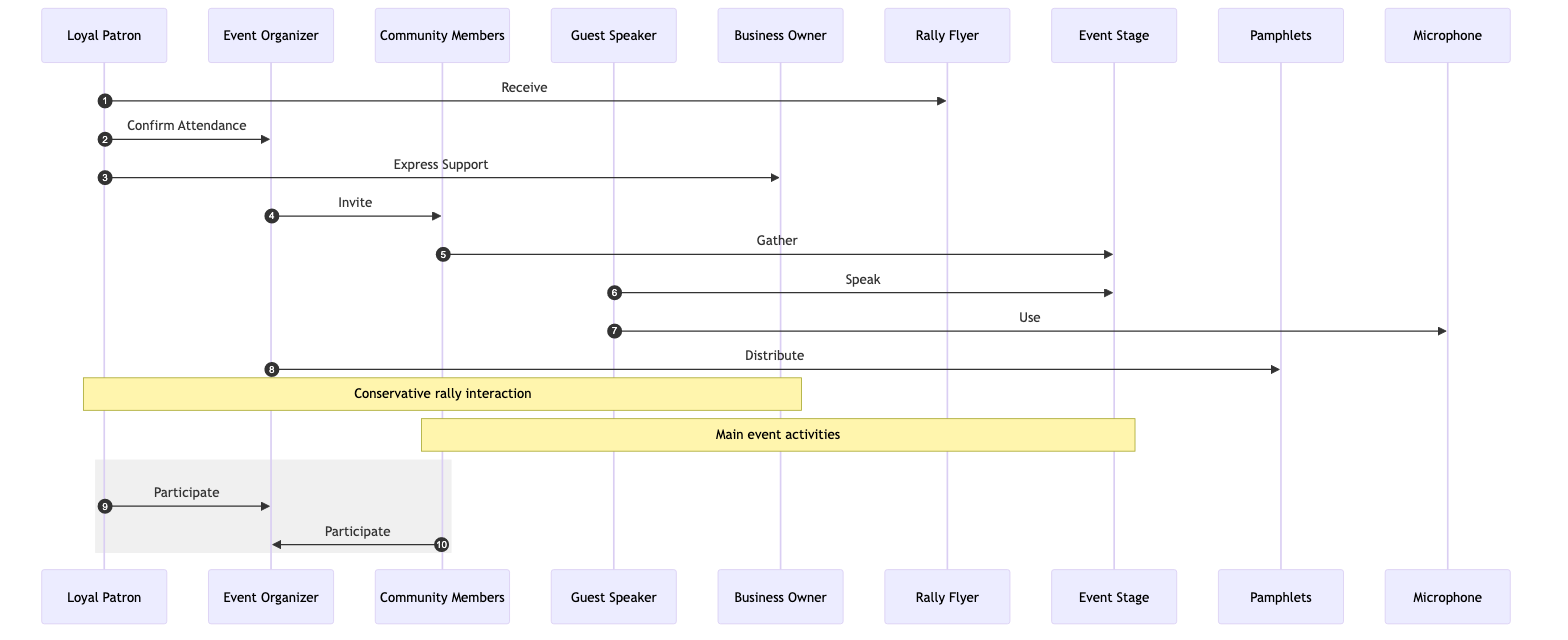What is the first action taken by the Loyal Patron? The first action listed in the interaction sequence is the Loyal Patron receiving the Rally Flyer. This is shown as the first arrow pointing from the Loyal Patron to the Rally Flyer in the diagram.
Answer: Receive Who does the Event Organizer invite? According to the interactions, the Event Organizer invites Community Members. This is explicitly stated in the action connecting the Event Organizer to the Community Members.
Answer: Community Members How many documents are involved in the interactions? The diagram shows two documents: the Rally Flyer and Pamphlets. Counting these gives a total of two documents mentioned in the interactions.
Answer: 2 What equipment does the Guest Speaker use during the rally? The diagram indicates that the Guest Speaker uses a Microphone during their interaction at the Event Stage, as shown in the separate action connecting the Guest Speaker to the Microphone.
Answer: Microphone What is the final action taken by the Event Organizer? The final action taken by the Event Organizer in the sequence is to distribute Pamphlets to the participants, as illustrated by the last interaction connecting the Event Organizer to the Pamphlets.
Answer: Distribute How is the Loyal Patron's relationship with the Business Owner characterized in the diagram? The Loyal Patron expresses support to the Business Owner, indicating a positive relationship and engagement. This is represented by the interaction between these two actors in the diagram.
Answer: Express Support What do the Community Members do after being invited? After being invited by the Event Organizer, the Community Members gather at the Event Stage, as indicated by the subsequent interaction in the flow of the diagram.
Answer: Gather What occurs between the Loyal Patron and the Event Organizer? The Loyal Patron confirms attendance to the Event Organizer, which shows a commitment to the rally and indicates a direct interaction between these two actors in the diagram.
Answer: Confirm Attendance What role does the Guest Speaker play at the rally? The Guest Speaker's role is to speak at the Event Stage, as described in the action that connects them to the Event Stage. This reflects a key part of their participation in the event.
Answer: Speak 